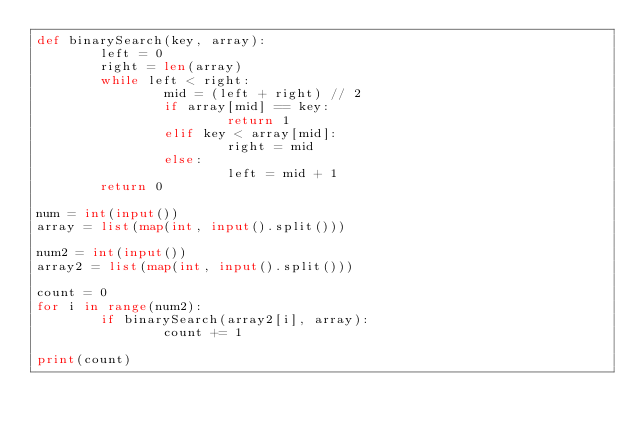Convert code to text. <code><loc_0><loc_0><loc_500><loc_500><_Python_>def binarySearch(key, array):
        left = 0
        right = len(array)
        while left < right:
                mid = (left + right) // 2
                if array[mid] == key:
                        return 1
                elif key < array[mid]:
                        right = mid
                else:
                        left = mid + 1
        return 0

num = int(input())
array = list(map(int, input().split()))

num2 = int(input())
array2 = list(map(int, input().split()))

count = 0
for i in range(num2):
        if binarySearch(array2[i], array):
                count += 1

print(count)
</code> 